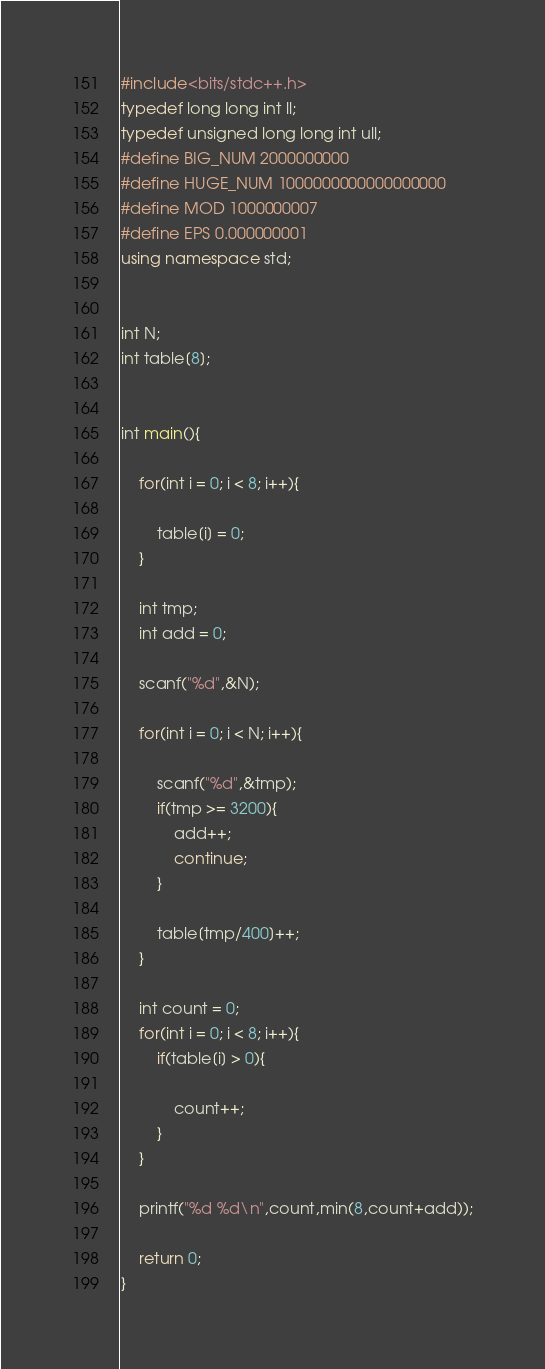<code> <loc_0><loc_0><loc_500><loc_500><_C++_>#include<bits/stdc++.h>
typedef long long int ll;
typedef unsigned long long int ull;
#define BIG_NUM 2000000000
#define HUGE_NUM 1000000000000000000
#define MOD 1000000007
#define EPS 0.000000001
using namespace std;


int N;
int table[8];


int main(){

	for(int i = 0; i < 8; i++){

		table[i] = 0;
	}

	int tmp;
	int add = 0;

	scanf("%d",&N);

	for(int i = 0; i < N; i++){

		scanf("%d",&tmp);
		if(tmp >= 3200){
			add++;
			continue;
		}

		table[tmp/400]++;
	}

	int count = 0;
	for(int i = 0; i < 8; i++){
		if(table[i] > 0){

			count++;
		}
	}

	printf("%d %d\n",count,min(8,count+add));

	return 0;
}
</code> 